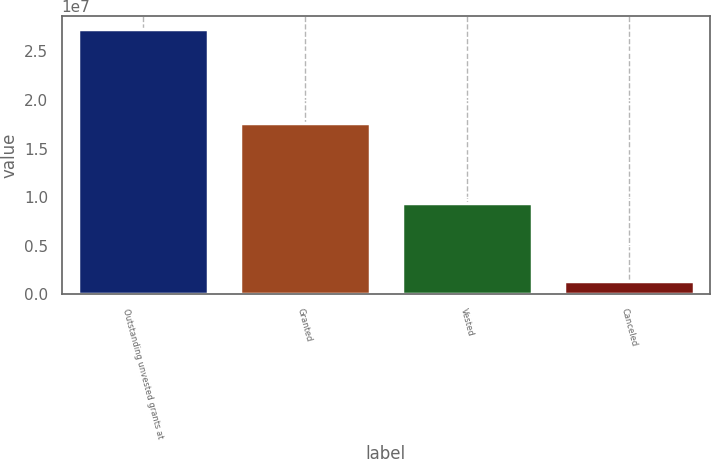Convert chart. <chart><loc_0><loc_0><loc_500><loc_500><bar_chart><fcel>Outstanding unvested grants at<fcel>Granted<fcel>Vested<fcel>Canceled<nl><fcel>2.72781e+07<fcel>1.75997e+07<fcel>9.40984e+06<fcel>1.36136e+06<nl></chart> 